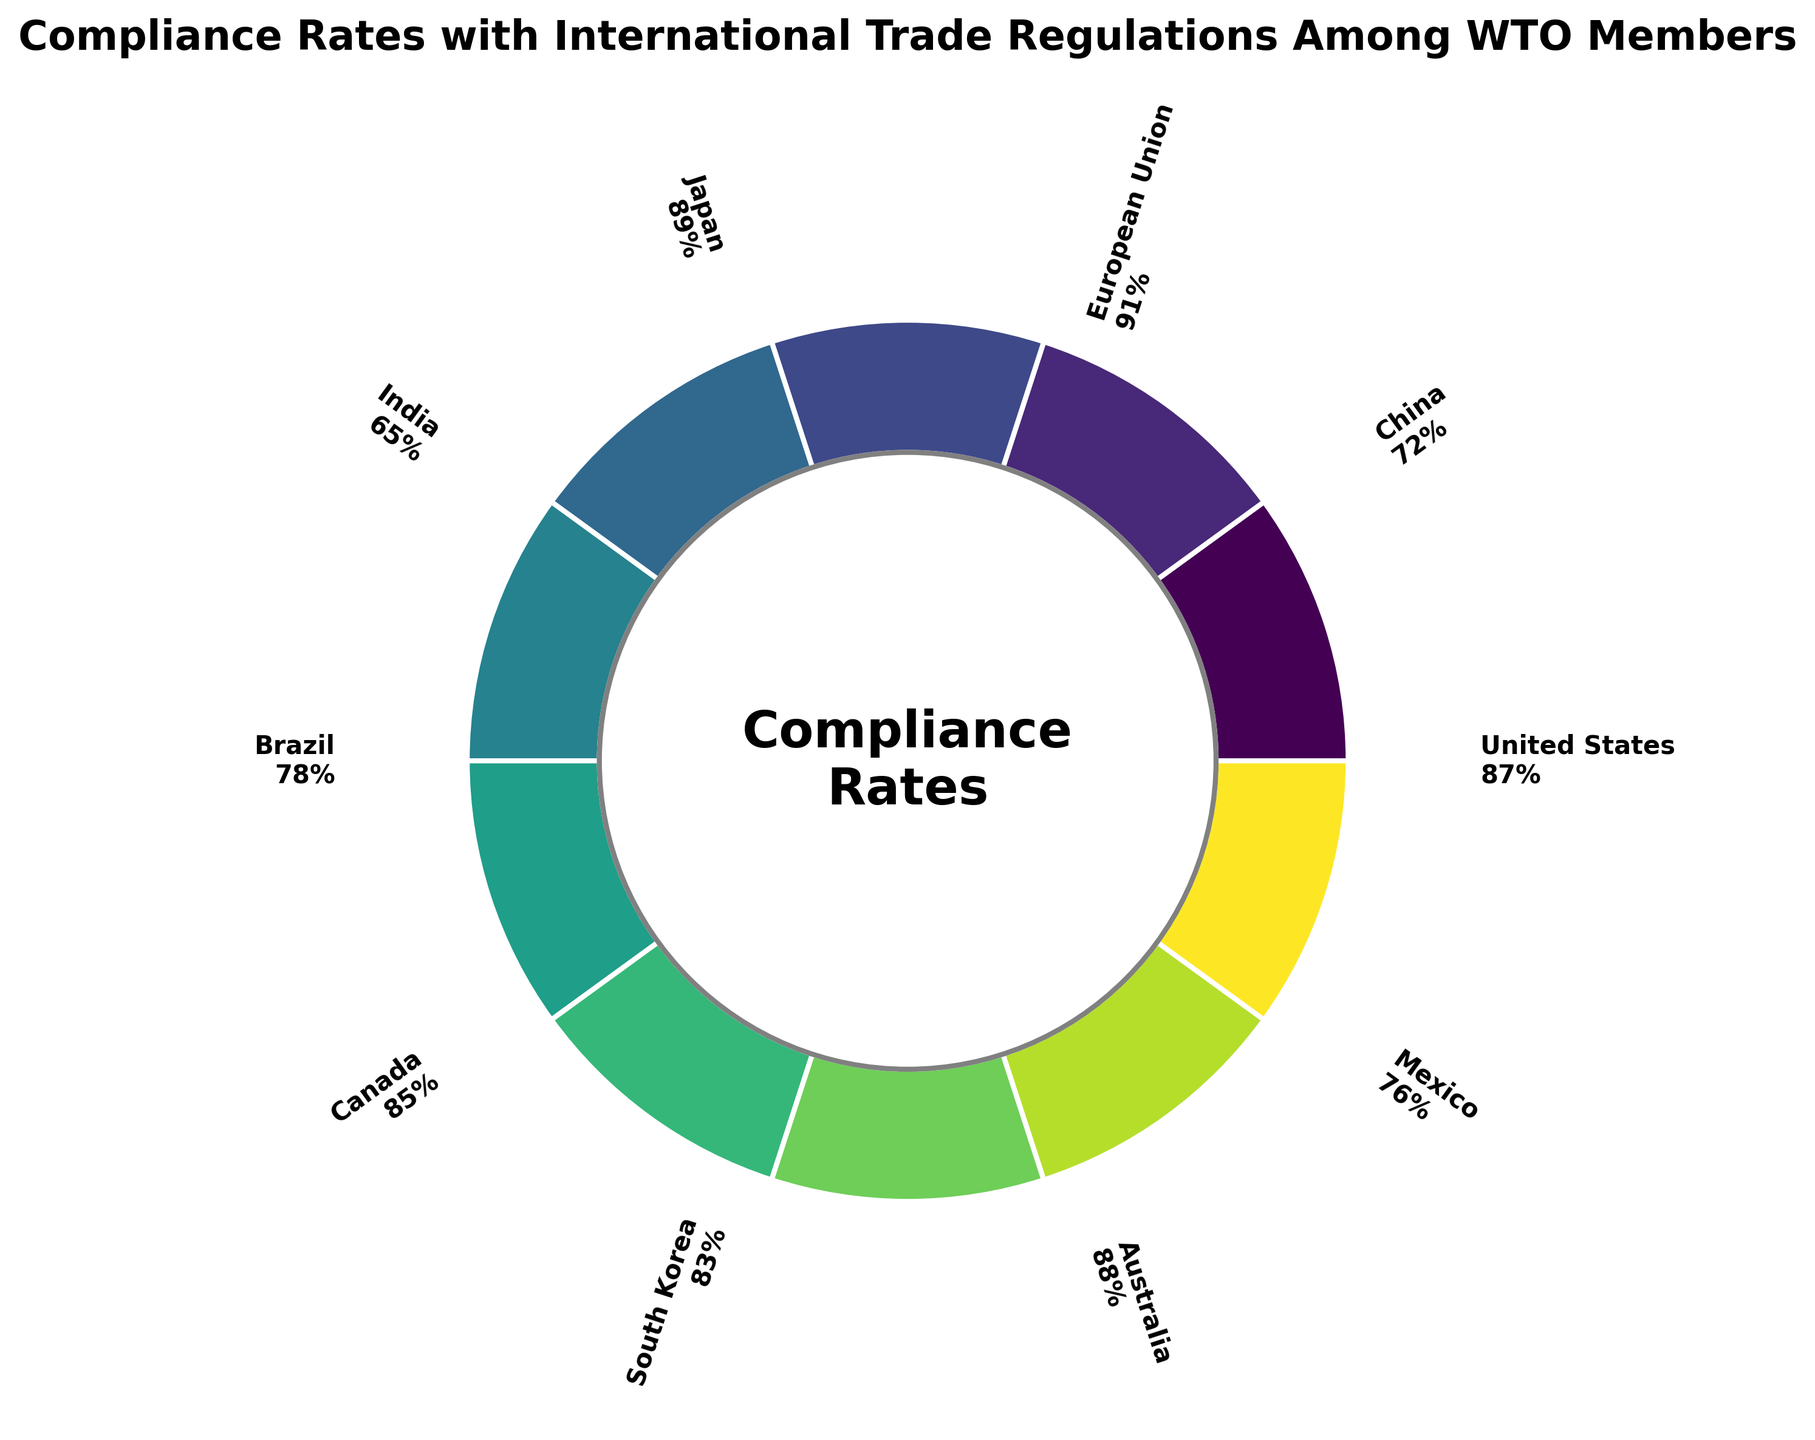Which country has the highest compliance rate? From the figure, the country with the highest compliance rate is clearly labeled with the highest percentage.
Answer: European Union What is the average compliance rate of the countries listed? To find the average, sum all the compliance rates and divide by the number of countries. The sum of the compliance rates is 87 + 72 + 91 + 89 + 65 + 78 + 85 + 83 + 88 + 76 = 814. There are 10 countries. So, the average is 814 / 10.
Answer: 81.4 How many countries have a compliance rate above 80%? By inspecting the labels, count the countries where the compliance rate exceeds 80%. These are United States, European Union, Japan, Canada, South Korea, and Australia.
Answer: 6 Which country has the lowest compliance rate and what is the rate? From the figure, the country with the lowest compliance rate is clearly labeled with the lowest percentage.
Answer: India with 65% Which countries have a compliance rate between 70% and 80%? Checking the labels, the countries with rates in this range are China, Brazil, and Mexico.
Answer: China, Brazil, and Mexico What is the difference between the highest and the lowest compliance rates? The highest rate is 91% (European Union) and the lowest rate is 65% (India). The difference is calculated by subtracting the lowest rate from the highest.
Answer: 26 Compare the compliance rates of the United States and China. Which country has a higher rate? The figure shows that the United States has a compliance rate of 87% and China has a rate of 72%. Thus, the United States has a higher rate.
Answer: United States What is the median compliance rate among the countries listed? First, arrange the compliance rates in numerical order: 65, 72, 76, 78, 83, 85, 87, 88, 89, 91. Since there are 10 numbers, the median is the average of the 5th and 6th numbers. (83 + 85) / 2
Answer: 84 If the average compliance rate is 81.4, how many countries have compliance rates above this average? By comparing each country's rate to the average, the United States, European Union, Japan, Australia, and Canada exceed the average of 81.4.
Answer: 5 What can you infer about the overall compliance with international trade regulations among the WTO members from the plot? The plot shows a range from 65% to 91%, indicating varying degrees of compliance among members, but most are above the average of 81.4%, suggesting generally good adherence.
Answer: Generally good adherence 